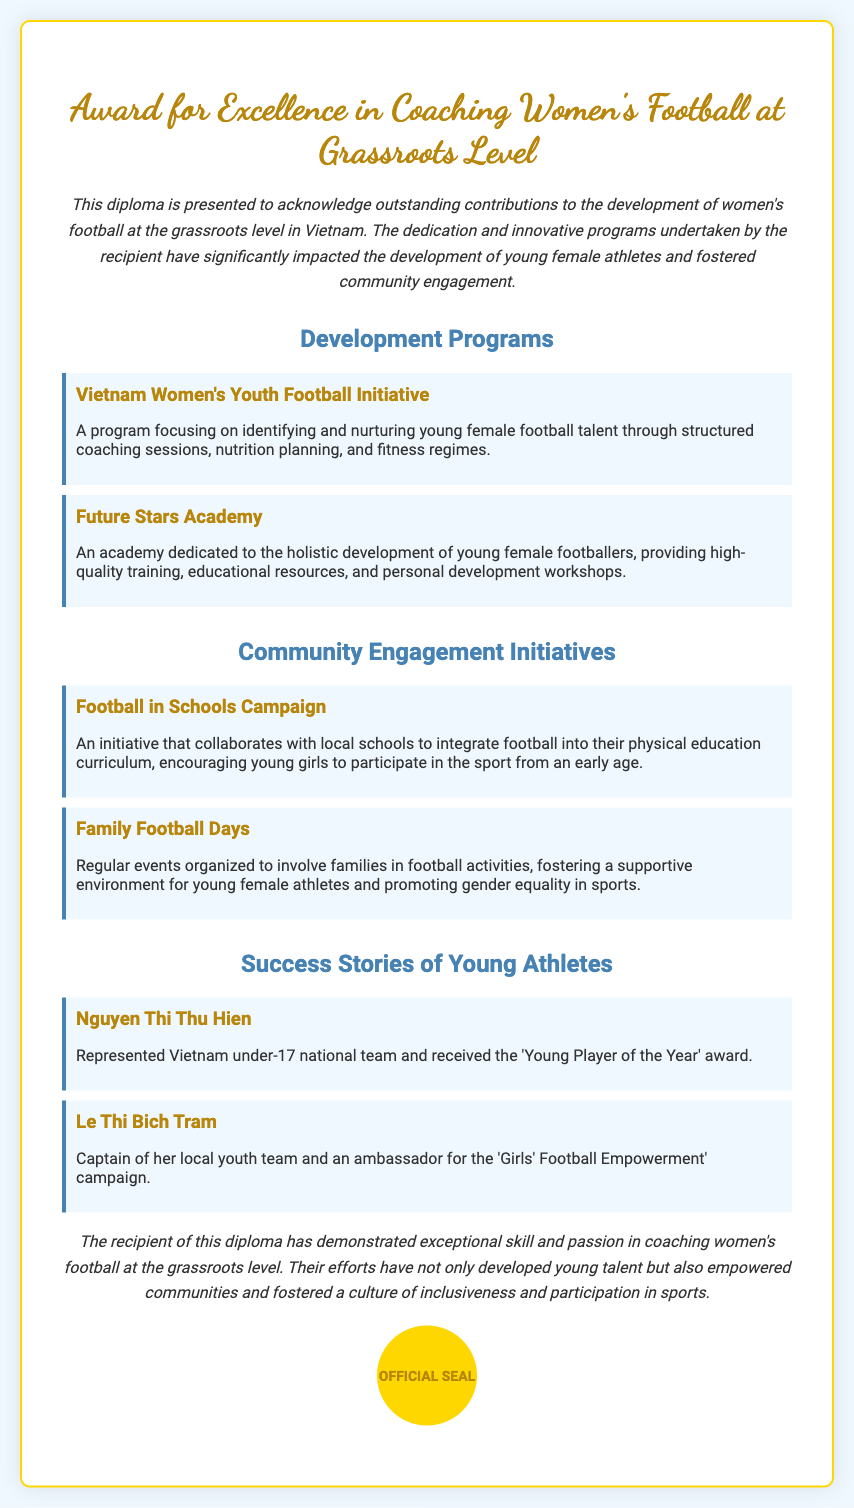What is the title of the diploma? The title of the diploma is found at the top of the document.
Answer: Award for Excellence in Coaching Women's Football at Grassroots Level How many development programs are mentioned in the document? The number of development programs can be counted in the respective section of the document.
Answer: 2 What is the name of the first development program listed? The first development program is specifically highlighted in the document under Development Programs.
Answer: Vietnam Women's Youth Football Initiative What initiative involves local schools? The initiative described in the community engagement section focuses on collaboration with educational institutions.
Answer: Football in Schools Campaign Who received the 'Young Player of the Year' award? This information can be found under the Success Stories of Young Athletes section.
Answer: Nguyen Thi Thu Hien What does the Family Football Days initiative promote? The purpose of the initiative is detailed in the document, emphasizing community involvement in sports.
Answer: Gender equality in sports Name the ambassador for the 'Girls' Football Empowerment' campaign. This information is found in the Success Stories section, referring to a specific individual.
Answer: Le Thi Bich Tram How is the recipient described in the conclusion? The conclusion summarizes the contributions of the recipient as stated in the document.
Answer: Exceptional skill and passion What color is the official seal? The document describes the seal's color in the styling of the diploma.
Answer: Gold 